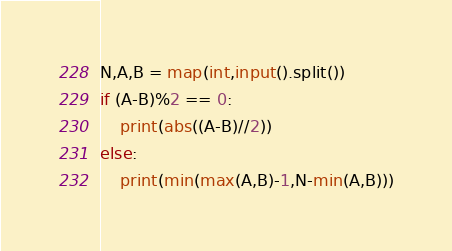<code> <loc_0><loc_0><loc_500><loc_500><_Python_>N,A,B = map(int,input().split())
if (A-B)%2 == 0:
    print(abs((A-B)//2))
else:
    print(min(max(A,B)-1,N-min(A,B)))</code> 